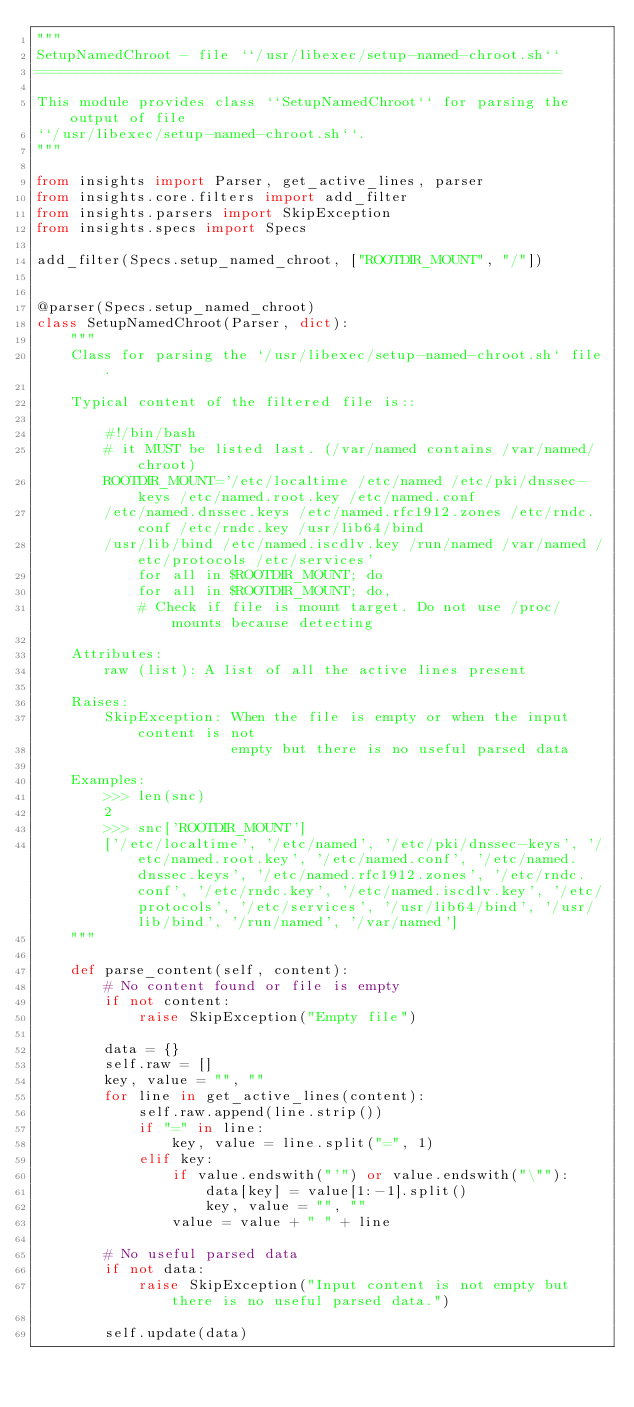<code> <loc_0><loc_0><loc_500><loc_500><_Python_>"""
SetupNamedChroot - file ``/usr/libexec/setup-named-chroot.sh``
==============================================================

This module provides class ``SetupNamedChroot`` for parsing the output of file
``/usr/libexec/setup-named-chroot.sh``.
"""

from insights import Parser, get_active_lines, parser
from insights.core.filters import add_filter
from insights.parsers import SkipException
from insights.specs import Specs

add_filter(Specs.setup_named_chroot, ["ROOTDIR_MOUNT", "/"])


@parser(Specs.setup_named_chroot)
class SetupNamedChroot(Parser, dict):
    """
    Class for parsing the `/usr/libexec/setup-named-chroot.sh` file.

    Typical content of the filtered file is::

        #!/bin/bash
        # it MUST be listed last. (/var/named contains /var/named/chroot)
        ROOTDIR_MOUNT='/etc/localtime /etc/named /etc/pki/dnssec-keys /etc/named.root.key /etc/named.conf
        /etc/named.dnssec.keys /etc/named.rfc1912.zones /etc/rndc.conf /etc/rndc.key /usr/lib64/bind
        /usr/lib/bind /etc/named.iscdlv.key /run/named /var/named /etc/protocols /etc/services'
            for all in $ROOTDIR_MOUNT; do
            for all in $ROOTDIR_MOUNT; do,
            # Check if file is mount target. Do not use /proc/mounts because detecting

    Attributes:
        raw (list): A list of all the active lines present

    Raises:
        SkipException: When the file is empty or when the input content is not
                       empty but there is no useful parsed data

    Examples:
        >>> len(snc)
        2
        >>> snc['ROOTDIR_MOUNT']
        ['/etc/localtime', '/etc/named', '/etc/pki/dnssec-keys', '/etc/named.root.key', '/etc/named.conf', '/etc/named.dnssec.keys', '/etc/named.rfc1912.zones', '/etc/rndc.conf', '/etc/rndc.key', '/etc/named.iscdlv.key', '/etc/protocols', '/etc/services', '/usr/lib64/bind', '/usr/lib/bind', '/run/named', '/var/named']
    """

    def parse_content(self, content):
        # No content found or file is empty
        if not content:
            raise SkipException("Empty file")

        data = {}
        self.raw = []
        key, value = "", ""
        for line in get_active_lines(content):
            self.raw.append(line.strip())
            if "=" in line:
                key, value = line.split("=", 1)
            elif key:
                if value.endswith("'") or value.endswith("\""):
                    data[key] = value[1:-1].split()
                    key, value = "", ""
                value = value + " " + line

        # No useful parsed data
        if not data:
            raise SkipException("Input content is not empty but there is no useful parsed data.")

        self.update(data)
</code> 